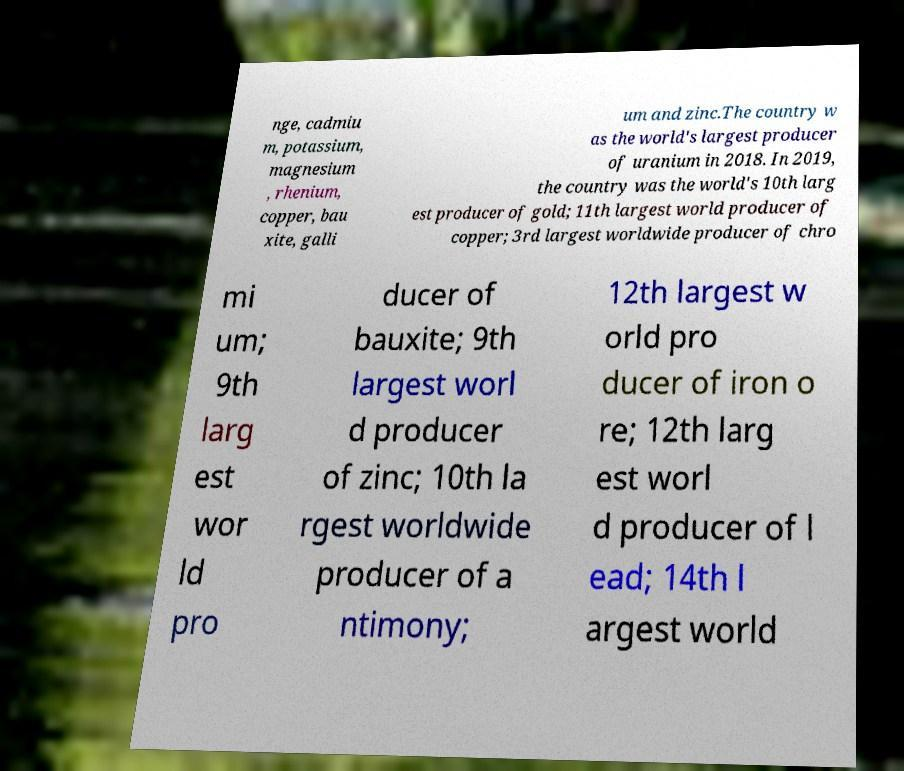Please read and relay the text visible in this image. What does it say? nge, cadmiu m, potassium, magnesium , rhenium, copper, bau xite, galli um and zinc.The country w as the world's largest producer of uranium in 2018. In 2019, the country was the world's 10th larg est producer of gold; 11th largest world producer of copper; 3rd largest worldwide producer of chro mi um; 9th larg est wor ld pro ducer of bauxite; 9th largest worl d producer of zinc; 10th la rgest worldwide producer of a ntimony; 12th largest w orld pro ducer of iron o re; 12th larg est worl d producer of l ead; 14th l argest world 